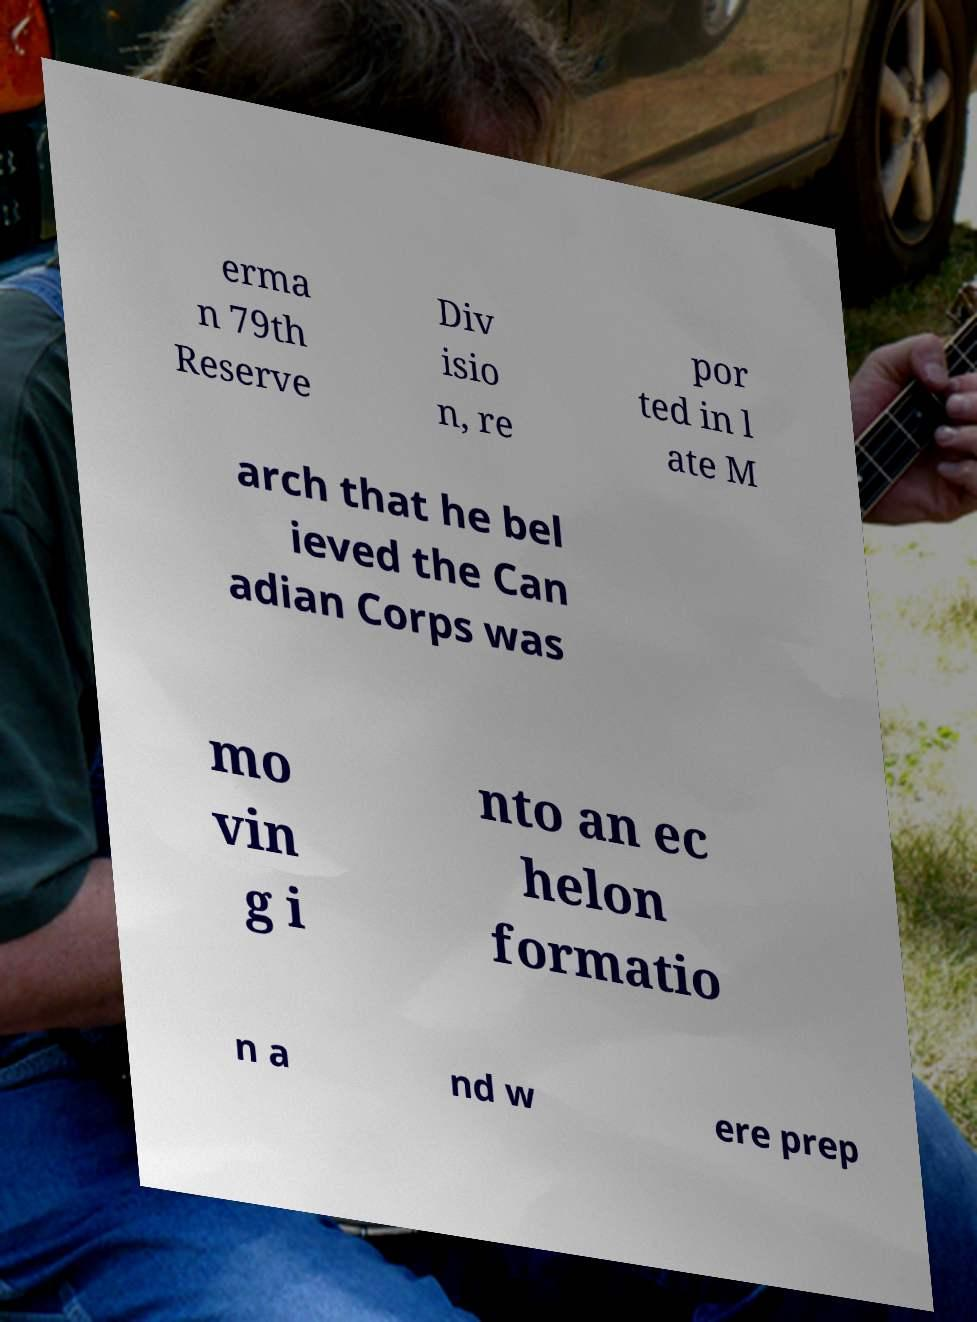Can you read and provide the text displayed in the image?This photo seems to have some interesting text. Can you extract and type it out for me? erma n 79th Reserve Div isio n, re por ted in l ate M arch that he bel ieved the Can adian Corps was mo vin g i nto an ec helon formatio n a nd w ere prep 